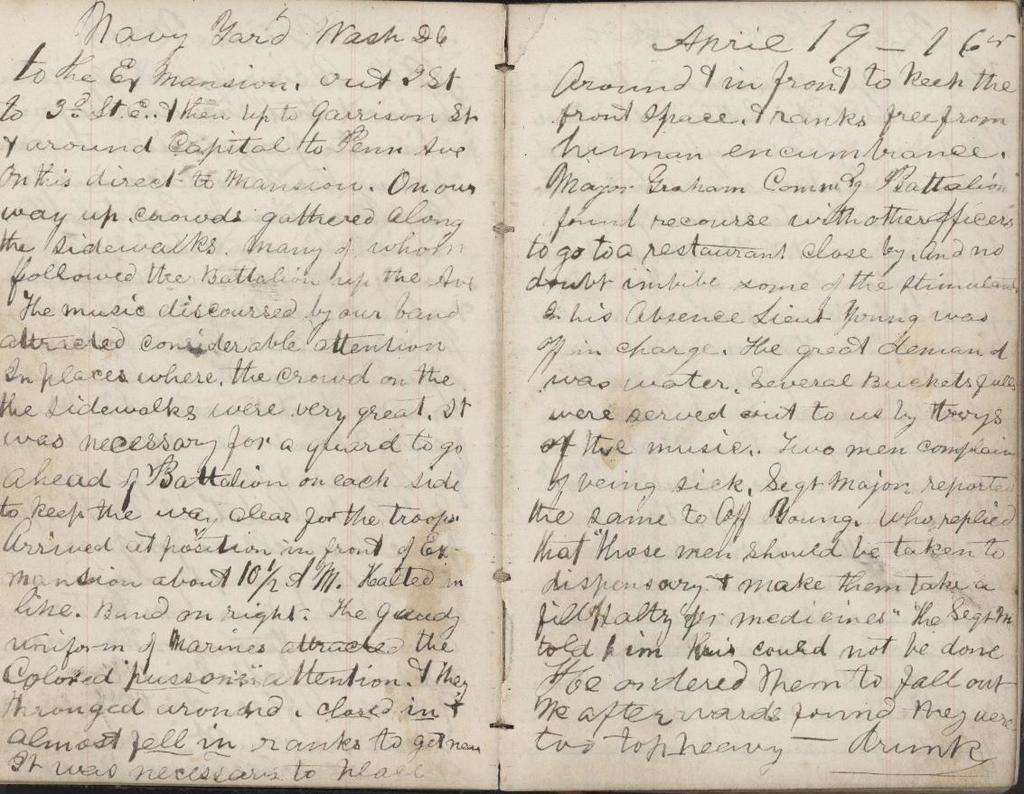<image>
Render a clear and concise summary of the photo. A handwritten book open with the date march 26 on the top right corner. 